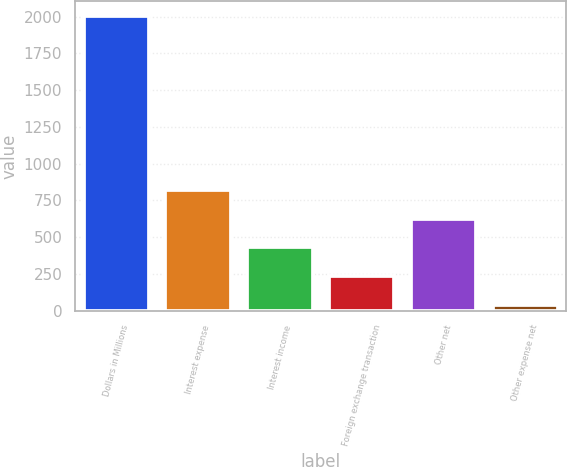Convert chart to OTSL. <chart><loc_0><loc_0><loc_500><loc_500><bar_chart><fcel>Dollars in Millions<fcel>Interest expense<fcel>Interest income<fcel>Foreign exchange transaction<fcel>Other net<fcel>Other expense net<nl><fcel>2005<fcel>824.2<fcel>430.6<fcel>233.8<fcel>627.4<fcel>37<nl></chart> 